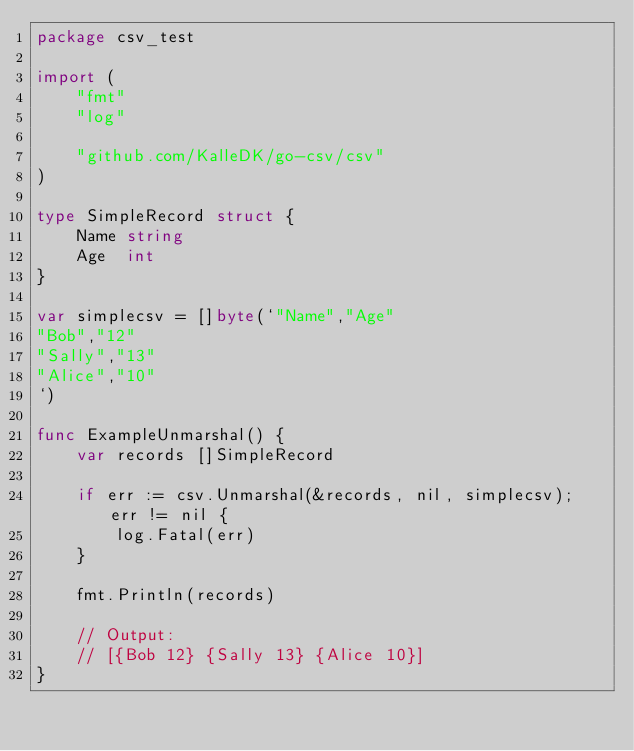Convert code to text. <code><loc_0><loc_0><loc_500><loc_500><_Go_>package csv_test

import (
	"fmt"
	"log"

	"github.com/KalleDK/go-csv/csv"
)

type SimpleRecord struct {
	Name string
	Age  int
}

var simplecsv = []byte(`"Name","Age"
"Bob","12"
"Sally","13"
"Alice","10"
`)

func ExampleUnmarshal() {
	var records []SimpleRecord

	if err := csv.Unmarshal(&records, nil, simplecsv); err != nil {
		log.Fatal(err)
	}

	fmt.Println(records)

	// Output:
	// [{Bob 12} {Sally 13} {Alice 10}]
}
</code> 